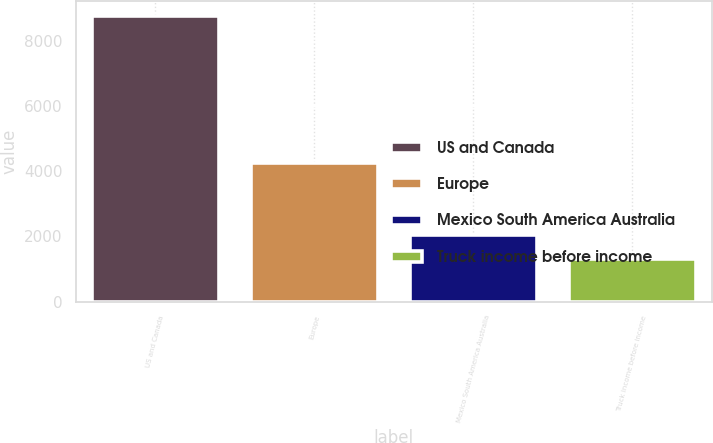Convert chart. <chart><loc_0><loc_0><loc_500><loc_500><bar_chart><fcel>US and Canada<fcel>Europe<fcel>Mexico South America Australia<fcel>Truck income before income<nl><fcel>8775.2<fcel>4254.9<fcel>2044.73<fcel>1296.9<nl></chart> 